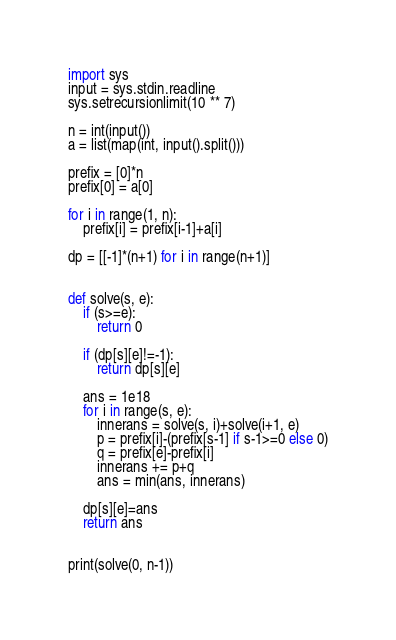<code> <loc_0><loc_0><loc_500><loc_500><_Python_>import sys
input = sys.stdin.readline
sys.setrecursionlimit(10 ** 7)

n = int(input())
a = list(map(int, input().split()))

prefix = [0]*n
prefix[0] = a[0]

for i in range(1, n):
    prefix[i] = prefix[i-1]+a[i]

dp = [[-1]*(n+1) for i in range(n+1)]


def solve(s, e):
    if (s>=e):
        return 0

    if (dp[s][e]!=-1):
        return dp[s][e]

    ans = 1e18
    for i in range(s, e):
        innerans = solve(s, i)+solve(i+1, e)
        p = prefix[i]-(prefix[s-1] if s-1>=0 else 0)
        q = prefix[e]-prefix[i]
        innerans += p+q
        ans = min(ans, innerans)
    
    dp[s][e]=ans
    return ans


print(solve(0, n-1))
</code> 